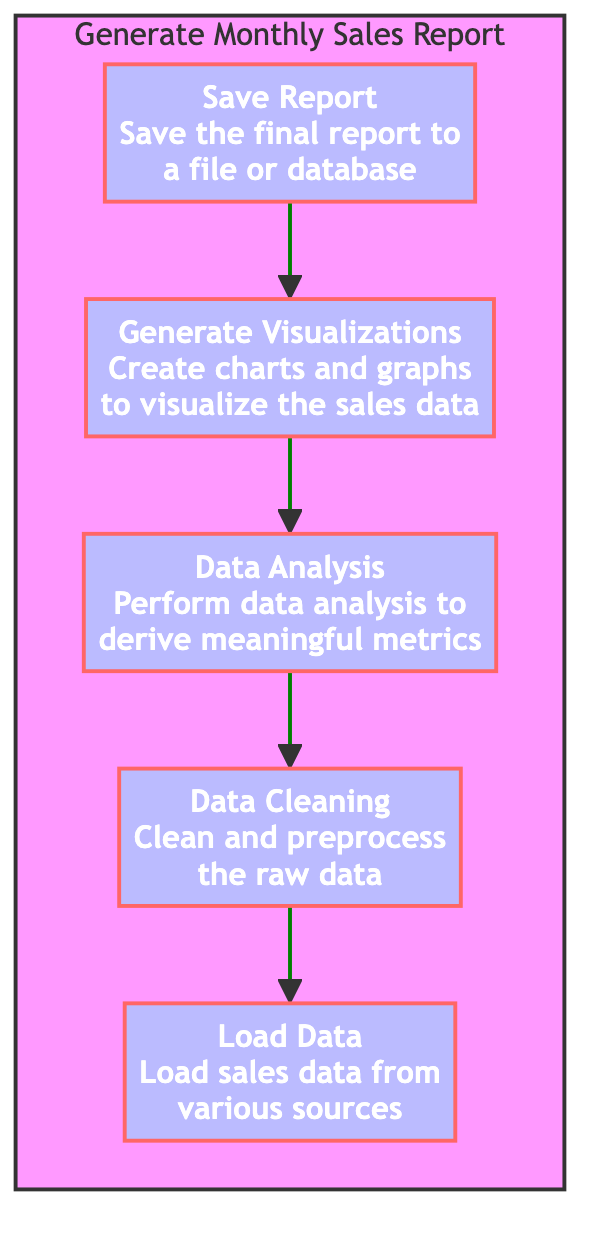What is the final step in the monthly sales report generation? The final step shown in the diagram is "Save Report", which is the last node in the upward flow.
Answer: Save Report How many distinct steps are there in the diagram? There are five distinct steps (Load Data, Data Cleaning, Data Analysis, Generate Visualizations, Save Report) represented in the flowchart.
Answer: Five Which step comes immediately before "Generate Visualizations"? The step immediately before "Generate Visualizations" is "Data Analysis", as it flows upward right before it.
Answer: Data Analysis What is the dependency of "Data Analysis"? The dependency of "Data Analysis" is "Data Cleaning", indicating that it cannot be performed until data is cleaned.
Answer: Data Cleaning What is the direct output of "Load Data"? The direct output of "Load Data" is "Data Cleaning", indicating that data cleaning starts directly after data is loaded.
Answer: Data Cleaning Which step has two dependencies before it? The step "Generate Visualizations" has one dependency, "Data Analysis", which in turn has a dependency that comes before it, "Data Cleaning". However, ultimately, only "Data Analysis" feeds directly into "Generate Visualizations", making it the step with a higher prerequisite.
Answer: Data Analysis Which two steps are at the beginning of the flow? The two steps at the beginning of the flow are "Load Data" and "Data Cleaning", with "Load Data" being the very first step, initiating the report generation.
Answer: Load Data What is the sequence of steps from loading data to saving the report? The sequence of steps is: Load Data → Data Cleaning → Data Analysis → Generate Visualizations → Save Report, following the upward path in the flowchart.
Answer: Load Data, Data Cleaning, Data Analysis, Generate Visualizations, Save Report Which step does not have any dependencies? The step "Load Data" does not have any dependencies, signifying that it is the starting point of the process.
Answer: Load Data 